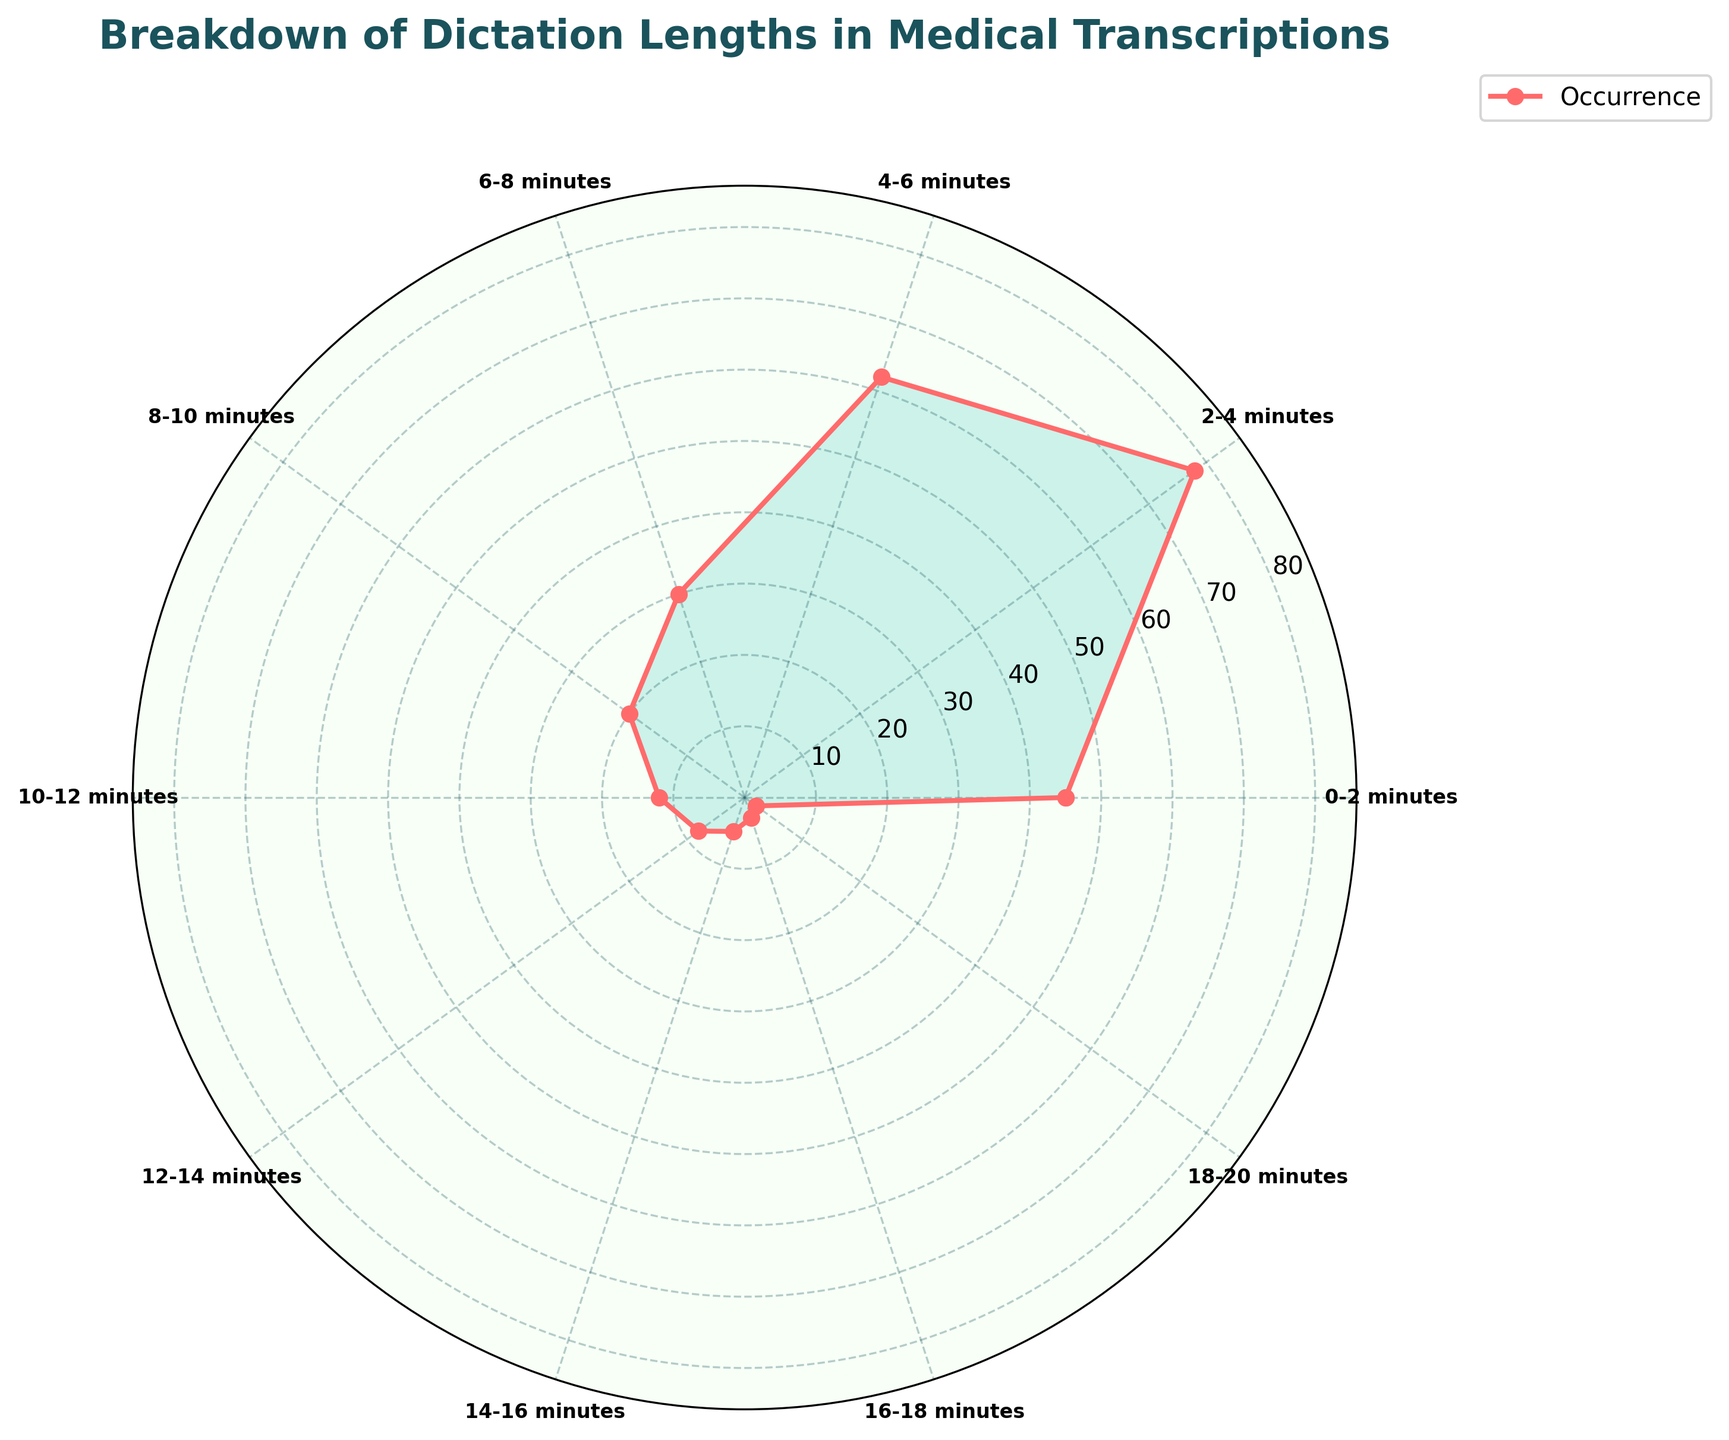What is the title of the figure? The title is clearly displayed at the top of the figure. It is meant to provide an overview of what the figure represents.
Answer: Breakdown of Dictation Lengths in Medical Transcriptions How many distinct dictation length categories are represented in the chart? To determine this, count each labeled segment along the circumference of the polar chart.
Answer: 10 Which dictation length category has the highest occurrence? By looking at the radial length of each segment, identify the one that extends furthest from the center, indicating the highest occurrence.
Answer: 2-4 minutes What is the total occurrence of dictations between 0 and 6 minutes? Sum the occurrences of the 0-2 minute, 2-4 minute, and 4-6 minute categories: 45 + 78 + 62.
Answer: 185 Compare the occurrences of dictations between 10 and 14 minutes, and 14 and 20 minutes. Which group has more occurrences? Add the occurrences for 10-12 minutes and 12-14 minutes, then compare it to the sum of 14-16 minutes, 16-18 minutes, and 18-20 minutes: (12+8) vs (5+3+2).
Answer: 10-14 minutes What is the average occurrence of dictations that last more than 12 minutes? Add the occurrences for all categories longer than 12 minutes and divide by the number of categories: (8+5+3+2)/4.
Answer: 4.5 Which dictation length category has the lowest occurrence? Identify the segment that reaches the shortest radial distance from the center on the polar chart.
Answer: 18-20 minutes What is the combined occurrence of dictations between 6 and 10 minutes? Sum the occurrences of the 6-8 and 8-10 minute categories: 30 + 20.
Answer: 50 Is the occurrence of dictations that last 4-6 minutes greater than the combined occurrence of those lasting 14-20 minutes? Compare the occurrence of 4-6 minutes (62) with the sum of occurrences in the 14-16, 16-18, and 18-20 minute categories: 62 vs (5+3+2).
Answer: Yes Which range has the second highest occurrence of dictations? Determine the second longest segment after identifying the longest one, which is for 2-4 minutes. The second highest will be the next longest segment.
Answer: 4-6 minutes 